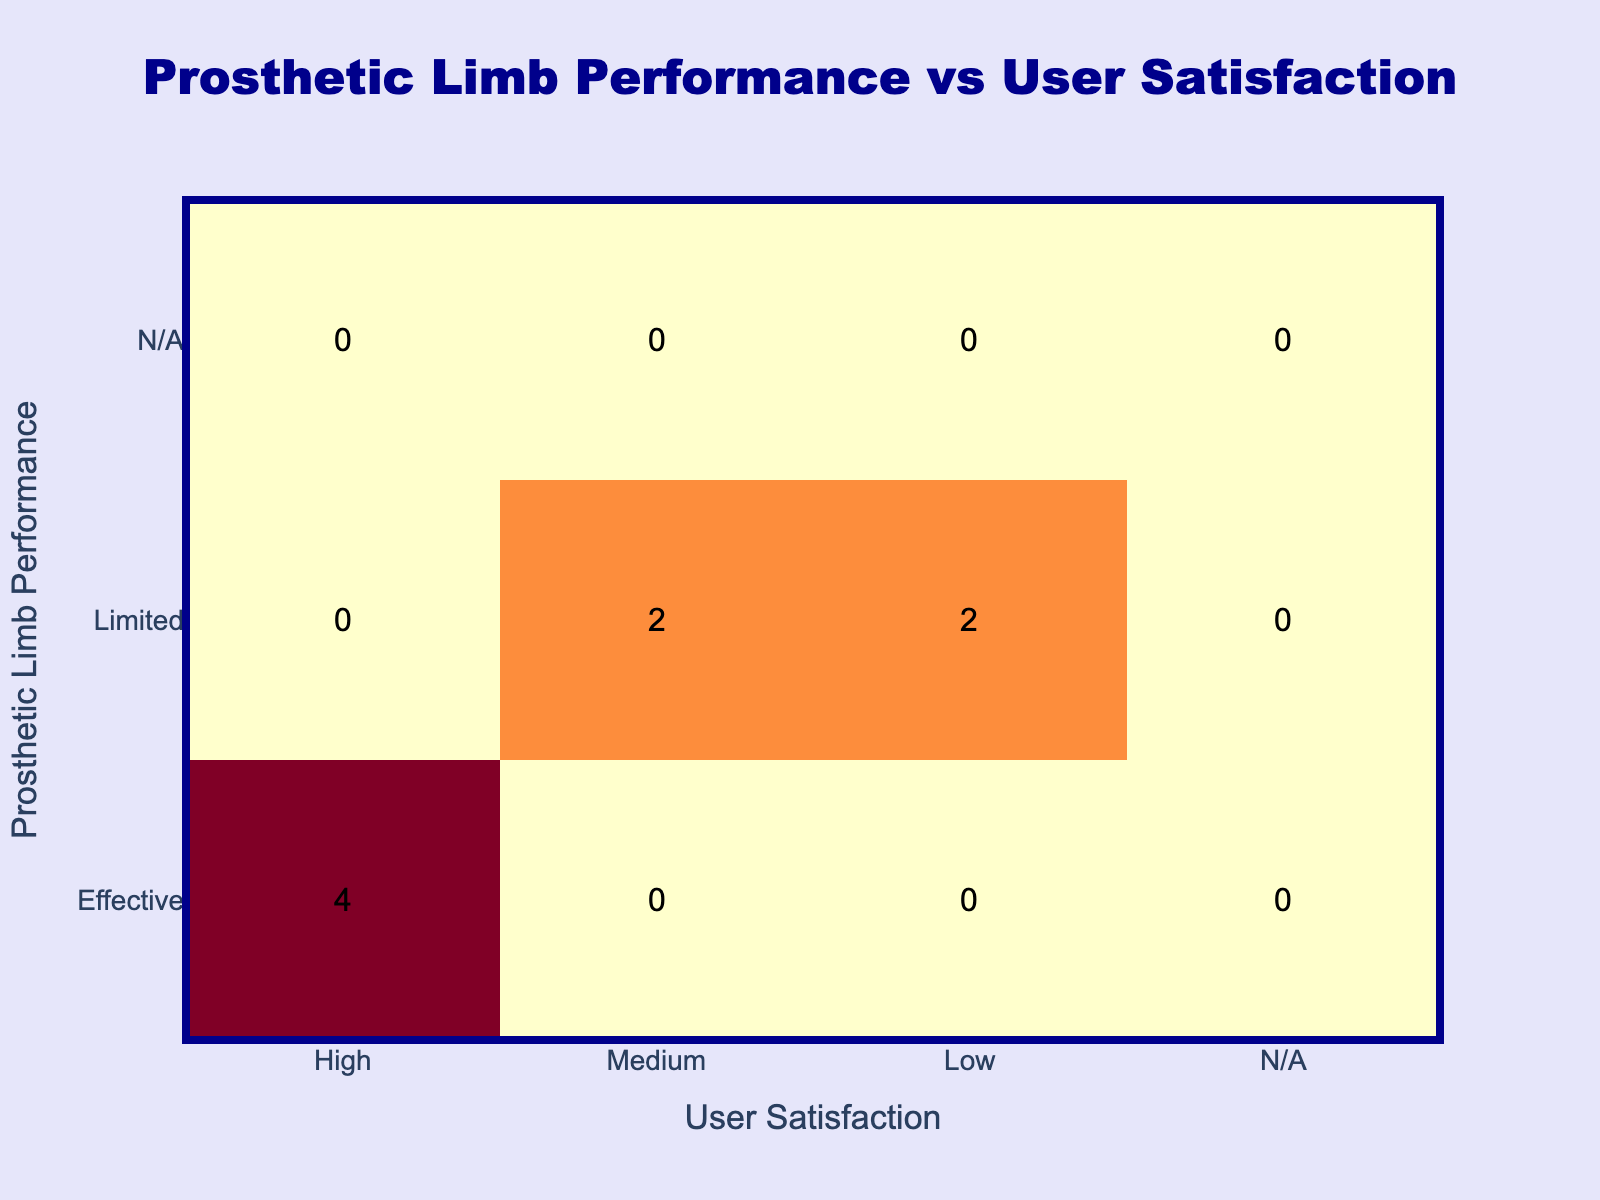What is the total count of "Effective" performance with "High" user satisfaction? From the table, there is one entry where the performance is "Effective" and the user satisfaction is "High", which occurs in the activity scenarios of Walking, Biking, Sit to Stand, and Daily Chores, totaling 4 instances.
Answer: 4 How many activities have "Limited" performance? The rows labeled "Limited" show activity scenarios including Running, Climbing Stairs, Hiking, and Yoga. Counting these scenarios, we find there are 4 activities with "Limited" performance.
Answer: 4 Is there any activity with "Not Applicable" performance that has a "High" user satisfaction? Reviewing the table, the activities that have "Not Applicable" performance are Swimming and Dance, both of which do not report any user satisfaction ratings as they are not applicable. Therefore, the answer is no.
Answer: No Which performance has the lowest number of occurrences in terms of user satisfaction? Looking at the counts for each performance with different user satisfaction levels, "Limited" performance has low instances at "Low" satisfaction with only 2 activities: Climbing Stairs and Yoga, while others have more. Therefore, it is the lowest count related to "Limited" performance.
Answer: Limited performance with Low satisfaction Which activity scenario has the highest user satisfaction and what is its performance? The activity scenarios that are "Effective" and have "High" user satisfaction include Walking, Biking, Sit to Stand, and Daily Chores. There are 4 such scenarios, making it the highest in terms of user satisfaction with "Effective" performance associated.
Answer: Walking, Biking, Sit to Stand, Daily Chores What is the total of "Medium" user satisfaction for "Effective" and "Limited" performance? Evaluating the table, "Effective" performance does not have any "Medium" entries. For "Limited" performance, we have 1 entry from Running and 1 from Hiking. Thus, the total comes down to 2 activities with "Medium" satisfaction under "Limited" performance.
Answer: 2 